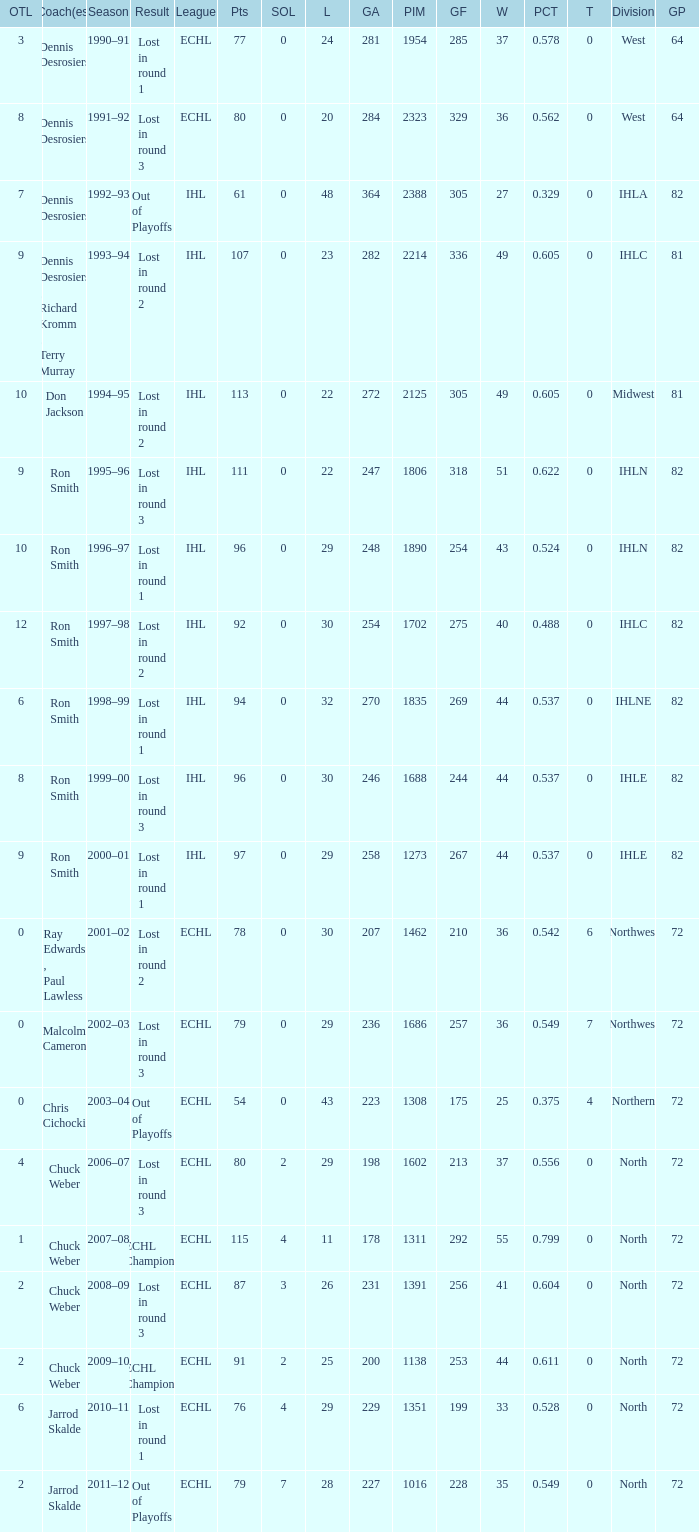What was the minimum L if the GA is 272? 22.0. 